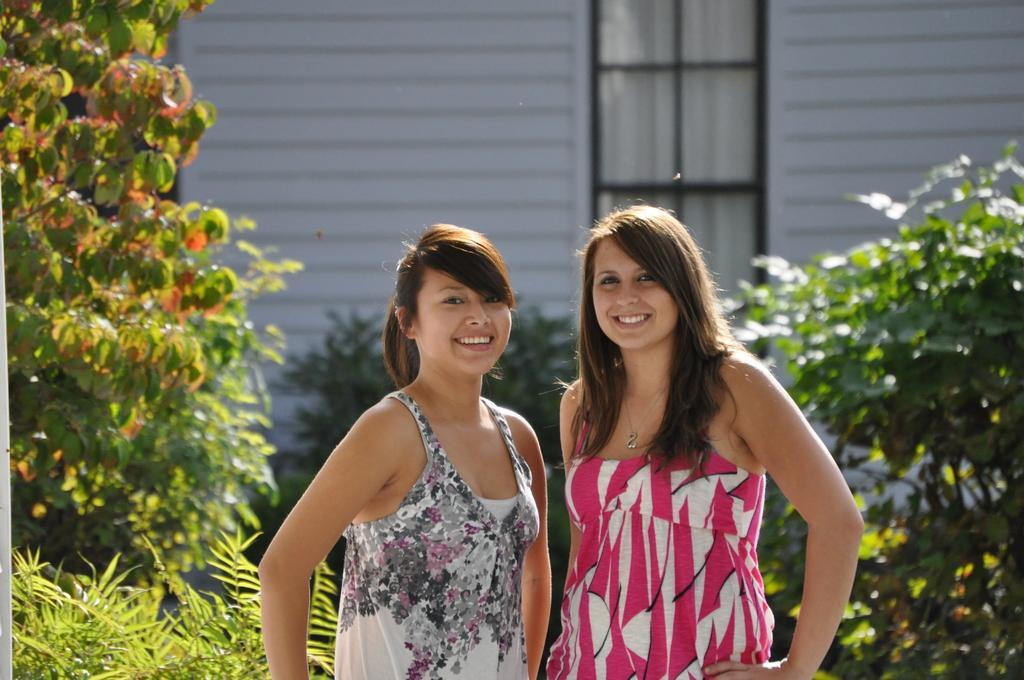In one or two sentences, can you explain what this image depicts? In this image, we can see two women are standing and smiling. In the background, we can see plants, wall and glass window. Through the glass we can see the curtain. 